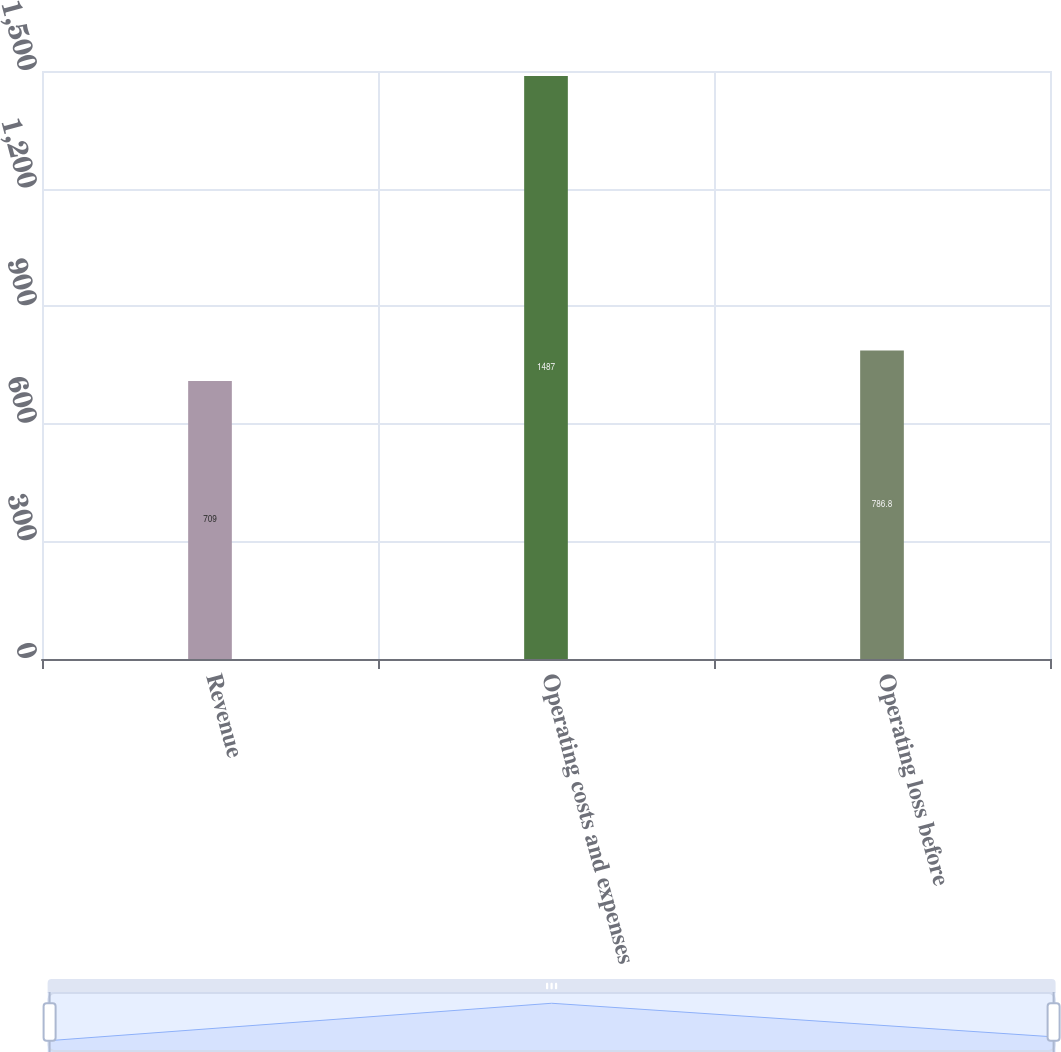Convert chart. <chart><loc_0><loc_0><loc_500><loc_500><bar_chart><fcel>Revenue<fcel>Operating costs and expenses<fcel>Operating loss before<nl><fcel>709<fcel>1487<fcel>786.8<nl></chart> 